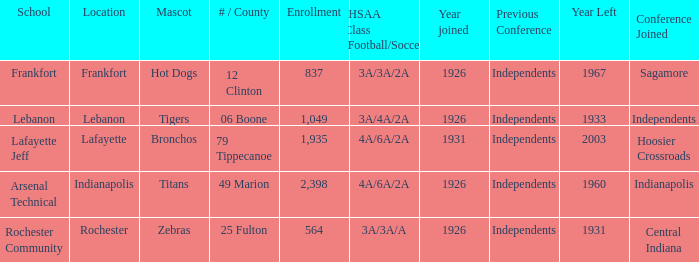What is the lowest enrollment that has Lafayette as the location? 1935.0. 